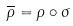<formula> <loc_0><loc_0><loc_500><loc_500>\overline { \rho } = \rho \circ \sigma</formula> 